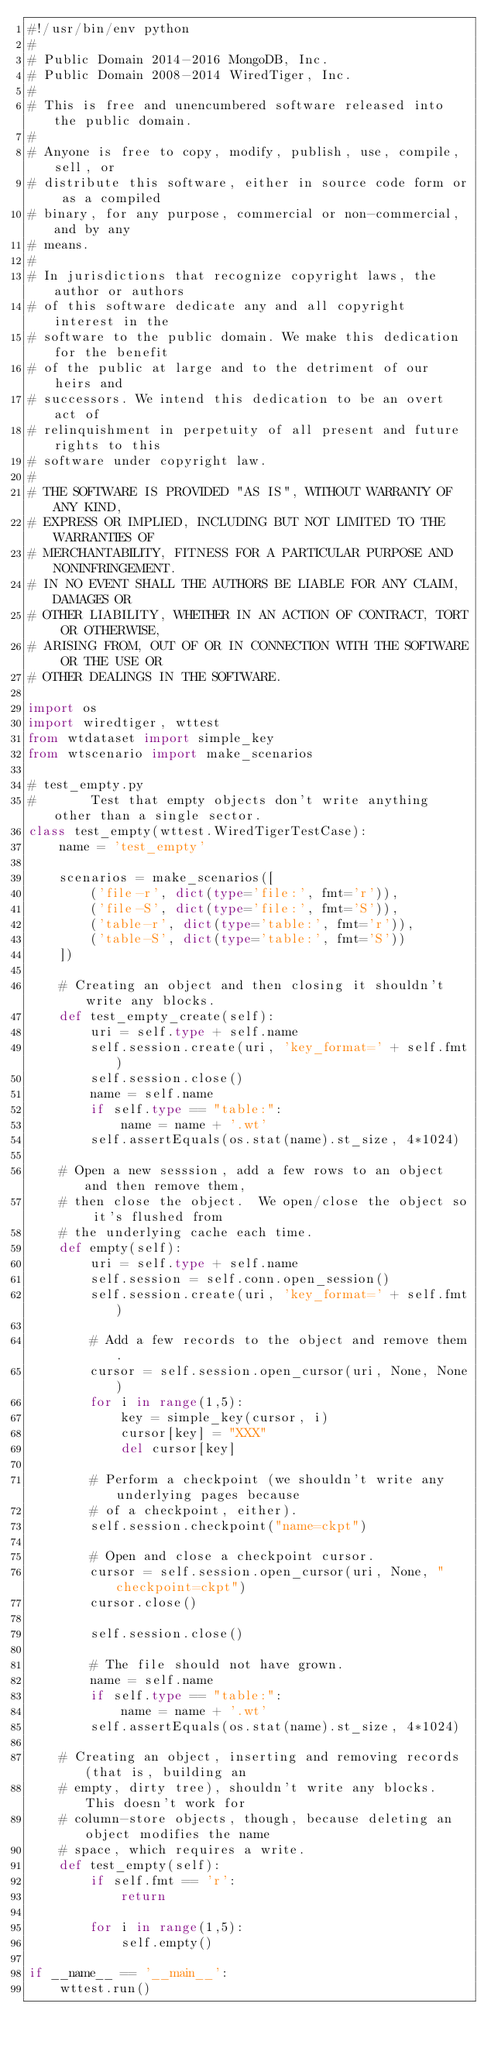<code> <loc_0><loc_0><loc_500><loc_500><_Python_>#!/usr/bin/env python
#
# Public Domain 2014-2016 MongoDB, Inc.
# Public Domain 2008-2014 WiredTiger, Inc.
#
# This is free and unencumbered software released into the public domain.
#
# Anyone is free to copy, modify, publish, use, compile, sell, or
# distribute this software, either in source code form or as a compiled
# binary, for any purpose, commercial or non-commercial, and by any
# means.
#
# In jurisdictions that recognize copyright laws, the author or authors
# of this software dedicate any and all copyright interest in the
# software to the public domain. We make this dedication for the benefit
# of the public at large and to the detriment of our heirs and
# successors. We intend this dedication to be an overt act of
# relinquishment in perpetuity of all present and future rights to this
# software under copyright law.
#
# THE SOFTWARE IS PROVIDED "AS IS", WITHOUT WARRANTY OF ANY KIND,
# EXPRESS OR IMPLIED, INCLUDING BUT NOT LIMITED TO THE WARRANTIES OF
# MERCHANTABILITY, FITNESS FOR A PARTICULAR PURPOSE AND NONINFRINGEMENT.
# IN NO EVENT SHALL THE AUTHORS BE LIABLE FOR ANY CLAIM, DAMAGES OR
# OTHER LIABILITY, WHETHER IN AN ACTION OF CONTRACT, TORT OR OTHERWISE,
# ARISING FROM, OUT OF OR IN CONNECTION WITH THE SOFTWARE OR THE USE OR
# OTHER DEALINGS IN THE SOFTWARE.

import os
import wiredtiger, wttest
from wtdataset import simple_key
from wtscenario import make_scenarios

# test_empty.py
#       Test that empty objects don't write anything other than a single sector.
class test_empty(wttest.WiredTigerTestCase):
    name = 'test_empty'

    scenarios = make_scenarios([
        ('file-r', dict(type='file:', fmt='r')),
        ('file-S', dict(type='file:', fmt='S')),
        ('table-r', dict(type='table:', fmt='r')),
        ('table-S', dict(type='table:', fmt='S'))
    ])

    # Creating an object and then closing it shouldn't write any blocks.
    def test_empty_create(self):
        uri = self.type + self.name
        self.session.create(uri, 'key_format=' + self.fmt)
        self.session.close()
        name = self.name
        if self.type == "table:":
            name = name + '.wt'
        self.assertEquals(os.stat(name).st_size, 4*1024)

    # Open a new sesssion, add a few rows to an object and then remove them,
    # then close the object.  We open/close the object so it's flushed from
    # the underlying cache each time.
    def empty(self):
        uri = self.type + self.name
        self.session = self.conn.open_session()
        self.session.create(uri, 'key_format=' + self.fmt)

        # Add a few records to the object and remove them.
        cursor = self.session.open_cursor(uri, None, None)
        for i in range(1,5):
            key = simple_key(cursor, i)
            cursor[key] = "XXX"
            del cursor[key]

        # Perform a checkpoint (we shouldn't write any underlying pages because
        # of a checkpoint, either).
        self.session.checkpoint("name=ckpt")

        # Open and close a checkpoint cursor.
        cursor = self.session.open_cursor(uri, None, "checkpoint=ckpt")
        cursor.close()

        self.session.close()

        # The file should not have grown.
        name = self.name
        if self.type == "table:":
            name = name + '.wt'
        self.assertEquals(os.stat(name).st_size, 4*1024)

    # Creating an object, inserting and removing records (that is, building an
    # empty, dirty tree), shouldn't write any blocks.  This doesn't work for
    # column-store objects, though, because deleting an object modifies the name
    # space, which requires a write.
    def test_empty(self):
        if self.fmt == 'r':
            return

        for i in range(1,5):
            self.empty()

if __name__ == '__main__':
    wttest.run()
</code> 